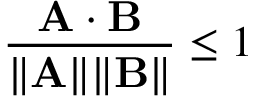Convert formula to latex. <formula><loc_0><loc_0><loc_500><loc_500>{ \frac { A \cdot B } { \| A \| \| B \| } } \leq 1</formula> 